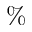Convert formula to latex. <formula><loc_0><loc_0><loc_500><loc_500>\%</formula> 